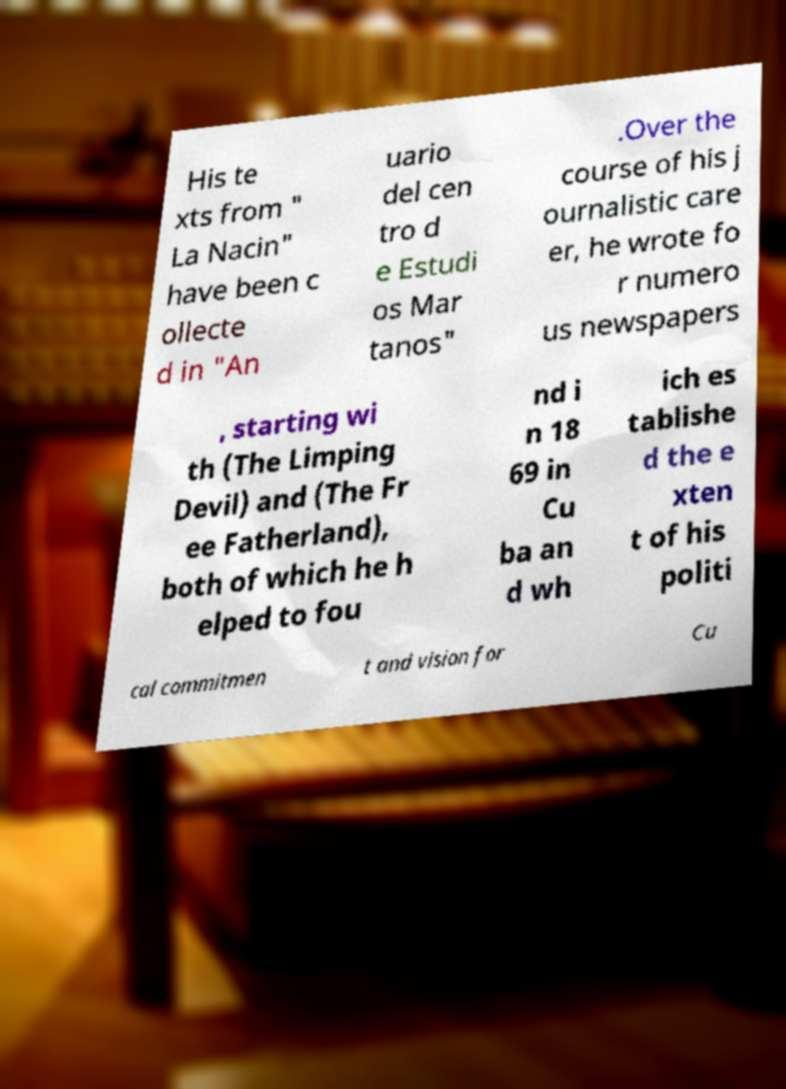Could you assist in decoding the text presented in this image and type it out clearly? His te xts from " La Nacin" have been c ollecte d in "An uario del cen tro d e Estudi os Mar tanos" .Over the course of his j ournalistic care er, he wrote fo r numero us newspapers , starting wi th (The Limping Devil) and (The Fr ee Fatherland), both of which he h elped to fou nd i n 18 69 in Cu ba an d wh ich es tablishe d the e xten t of his politi cal commitmen t and vision for Cu 